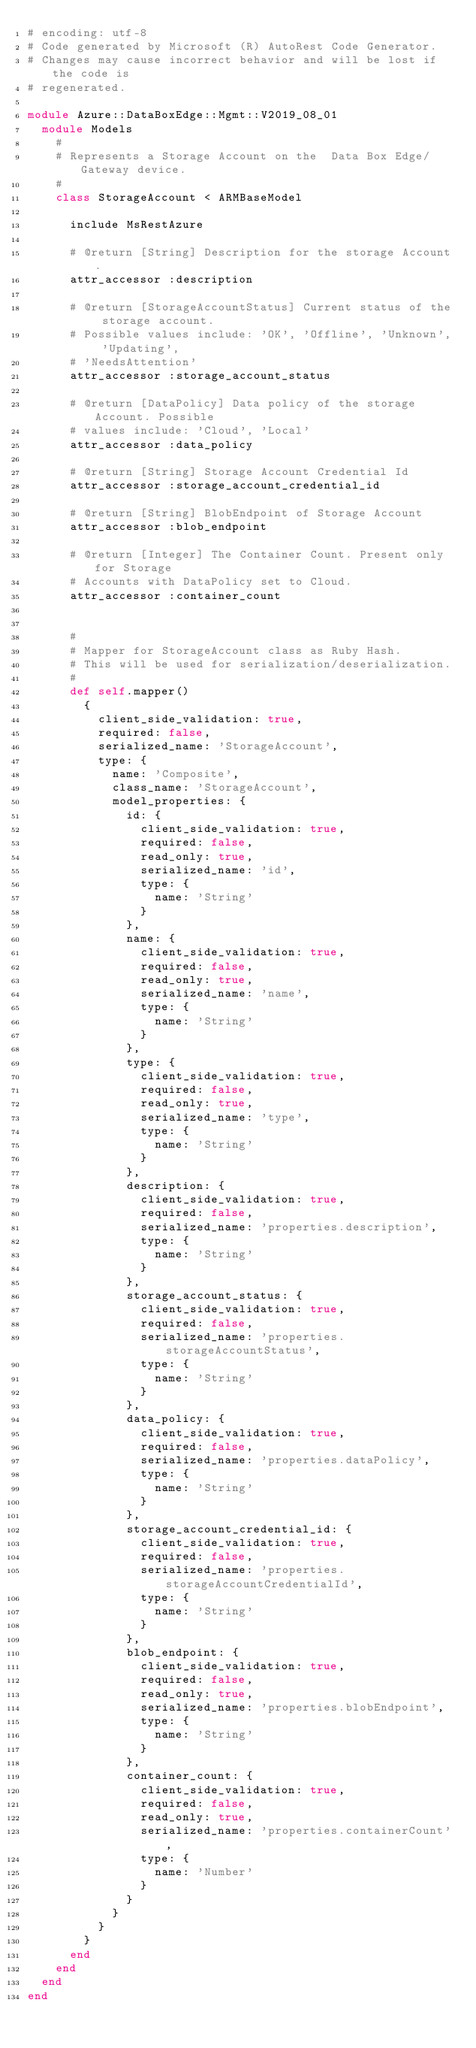<code> <loc_0><loc_0><loc_500><loc_500><_Ruby_># encoding: utf-8
# Code generated by Microsoft (R) AutoRest Code Generator.
# Changes may cause incorrect behavior and will be lost if the code is
# regenerated.

module Azure::DataBoxEdge::Mgmt::V2019_08_01
  module Models
    #
    # Represents a Storage Account on the  Data Box Edge/Gateway device.
    #
    class StorageAccount < ARMBaseModel

      include MsRestAzure

      # @return [String] Description for the storage Account.
      attr_accessor :description

      # @return [StorageAccountStatus] Current status of the storage account.
      # Possible values include: 'OK', 'Offline', 'Unknown', 'Updating',
      # 'NeedsAttention'
      attr_accessor :storage_account_status

      # @return [DataPolicy] Data policy of the storage Account. Possible
      # values include: 'Cloud', 'Local'
      attr_accessor :data_policy

      # @return [String] Storage Account Credential Id
      attr_accessor :storage_account_credential_id

      # @return [String] BlobEndpoint of Storage Account
      attr_accessor :blob_endpoint

      # @return [Integer] The Container Count. Present only for Storage
      # Accounts with DataPolicy set to Cloud.
      attr_accessor :container_count


      #
      # Mapper for StorageAccount class as Ruby Hash.
      # This will be used for serialization/deserialization.
      #
      def self.mapper()
        {
          client_side_validation: true,
          required: false,
          serialized_name: 'StorageAccount',
          type: {
            name: 'Composite',
            class_name: 'StorageAccount',
            model_properties: {
              id: {
                client_side_validation: true,
                required: false,
                read_only: true,
                serialized_name: 'id',
                type: {
                  name: 'String'
                }
              },
              name: {
                client_side_validation: true,
                required: false,
                read_only: true,
                serialized_name: 'name',
                type: {
                  name: 'String'
                }
              },
              type: {
                client_side_validation: true,
                required: false,
                read_only: true,
                serialized_name: 'type',
                type: {
                  name: 'String'
                }
              },
              description: {
                client_side_validation: true,
                required: false,
                serialized_name: 'properties.description',
                type: {
                  name: 'String'
                }
              },
              storage_account_status: {
                client_side_validation: true,
                required: false,
                serialized_name: 'properties.storageAccountStatus',
                type: {
                  name: 'String'
                }
              },
              data_policy: {
                client_side_validation: true,
                required: false,
                serialized_name: 'properties.dataPolicy',
                type: {
                  name: 'String'
                }
              },
              storage_account_credential_id: {
                client_side_validation: true,
                required: false,
                serialized_name: 'properties.storageAccountCredentialId',
                type: {
                  name: 'String'
                }
              },
              blob_endpoint: {
                client_side_validation: true,
                required: false,
                read_only: true,
                serialized_name: 'properties.blobEndpoint',
                type: {
                  name: 'String'
                }
              },
              container_count: {
                client_side_validation: true,
                required: false,
                read_only: true,
                serialized_name: 'properties.containerCount',
                type: {
                  name: 'Number'
                }
              }
            }
          }
        }
      end
    end
  end
end
</code> 